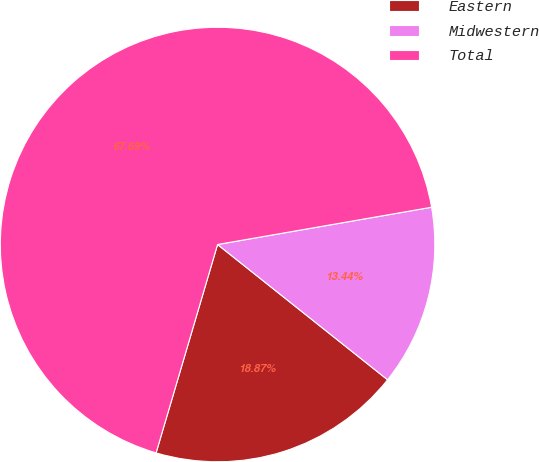Convert chart. <chart><loc_0><loc_0><loc_500><loc_500><pie_chart><fcel>Eastern<fcel>Midwestern<fcel>Total<nl><fcel>18.87%<fcel>13.44%<fcel>67.69%<nl></chart> 